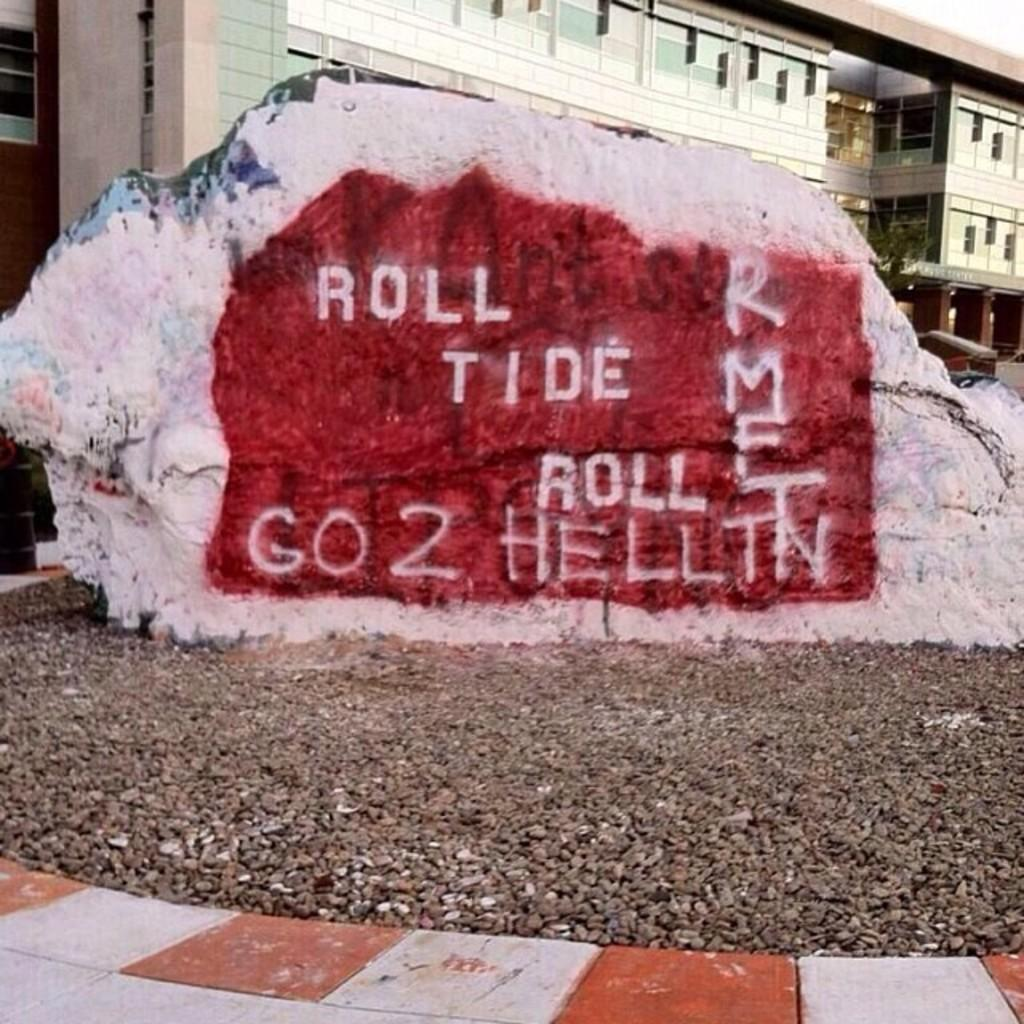What is the largest object in the image? There is a big stone in the image. What type of structure can be seen in the image? There is a building in the image. What part of the natural environment is visible in the image? The sky is visible in the image. What is written or engraved on the stone? There is text on the stone. How many pieces of pie are on the stone in the image? There is no pie present in the image; it features a big stone with text on it. What type of wealth is depicted on the stone in the image? There is no depiction of wealth on the stone; it only has text on it. 